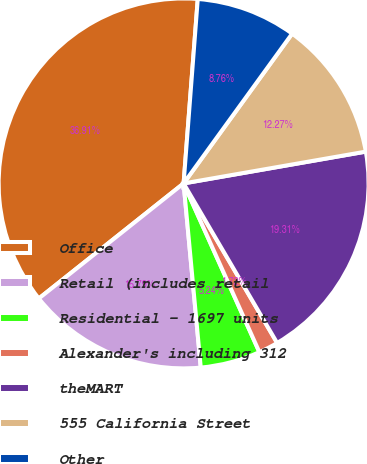Convert chart to OTSL. <chart><loc_0><loc_0><loc_500><loc_500><pie_chart><fcel>Office<fcel>Retail (includes retail<fcel>Residential - 1697 units<fcel>Alexander's including 312<fcel>theMART<fcel>555 California Street<fcel>Other<nl><fcel>36.91%<fcel>15.79%<fcel>5.24%<fcel>1.72%<fcel>19.31%<fcel>12.27%<fcel>8.76%<nl></chart> 